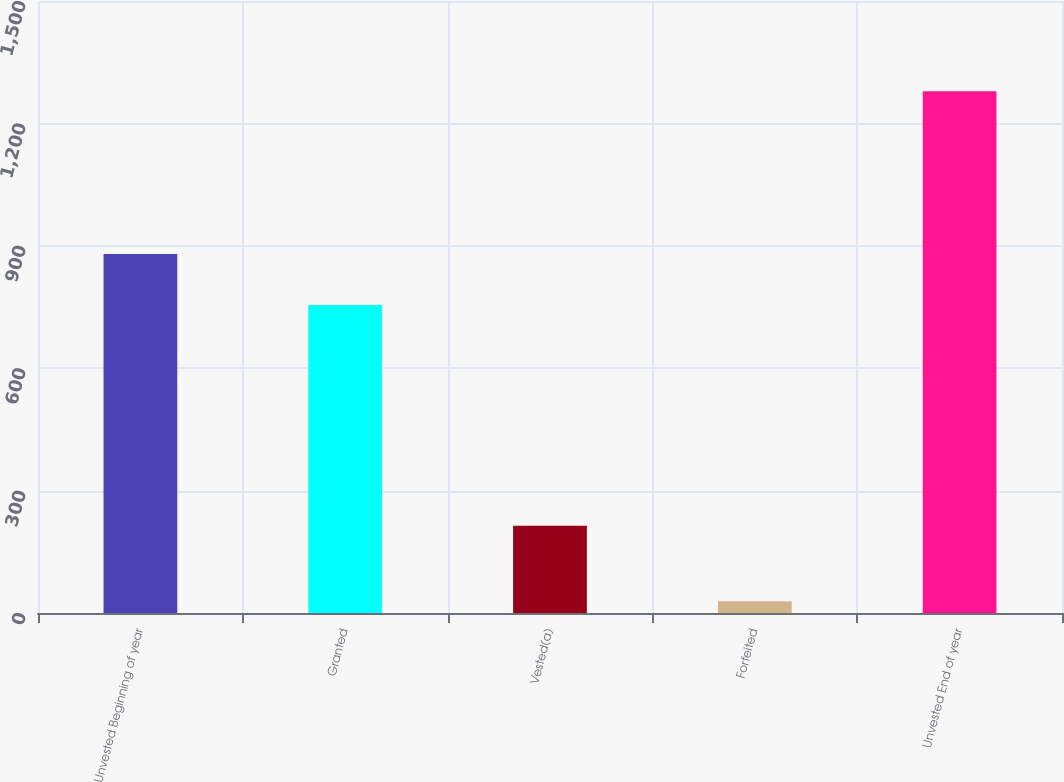Convert chart. <chart><loc_0><loc_0><loc_500><loc_500><bar_chart><fcel>Unvested Beginning of year<fcel>Granted<fcel>Vested(a)<fcel>Forfeited<fcel>Unvested End of year<nl><fcel>880<fcel>755<fcel>214<fcel>29<fcel>1279<nl></chart> 